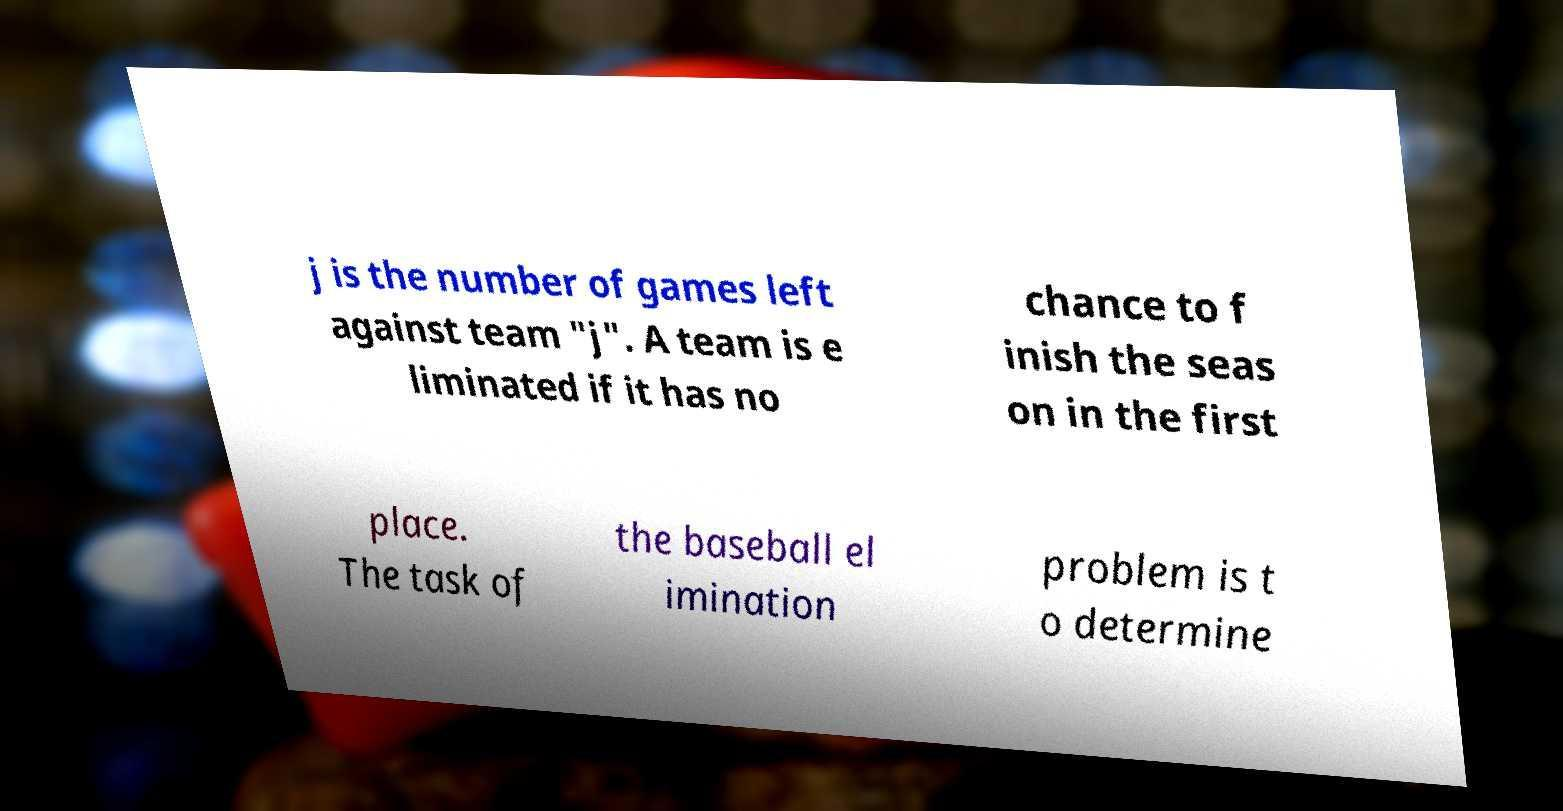For documentation purposes, I need the text within this image transcribed. Could you provide that? j is the number of games left against team "j". A team is e liminated if it has no chance to f inish the seas on in the first place. The task of the baseball el imination problem is t o determine 